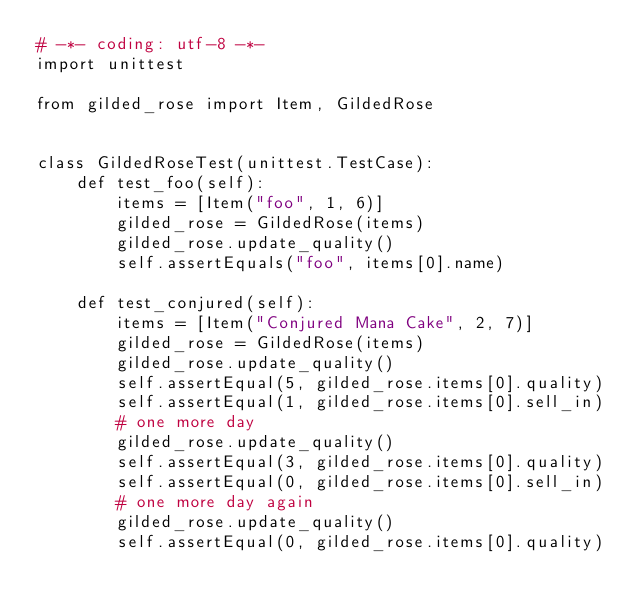<code> <loc_0><loc_0><loc_500><loc_500><_Python_># -*- coding: utf-8 -*-
import unittest

from gilded_rose import Item, GildedRose


class GildedRoseTest(unittest.TestCase):
    def test_foo(self):
        items = [Item("foo", 1, 6)]
        gilded_rose = GildedRose(items)
        gilded_rose.update_quality()
        self.assertEquals("foo", items[0].name)

    def test_conjured(self):
        items = [Item("Conjured Mana Cake", 2, 7)]
        gilded_rose = GildedRose(items)
        gilded_rose.update_quality()
        self.assertEqual(5, gilded_rose.items[0].quality)
        self.assertEqual(1, gilded_rose.items[0].sell_in)
        # one more day
        gilded_rose.update_quality()
        self.assertEqual(3, gilded_rose.items[0].quality)
        self.assertEqual(0, gilded_rose.items[0].sell_in)
        # one more day again
        gilded_rose.update_quality()
        self.assertEqual(0, gilded_rose.items[0].quality)</code> 